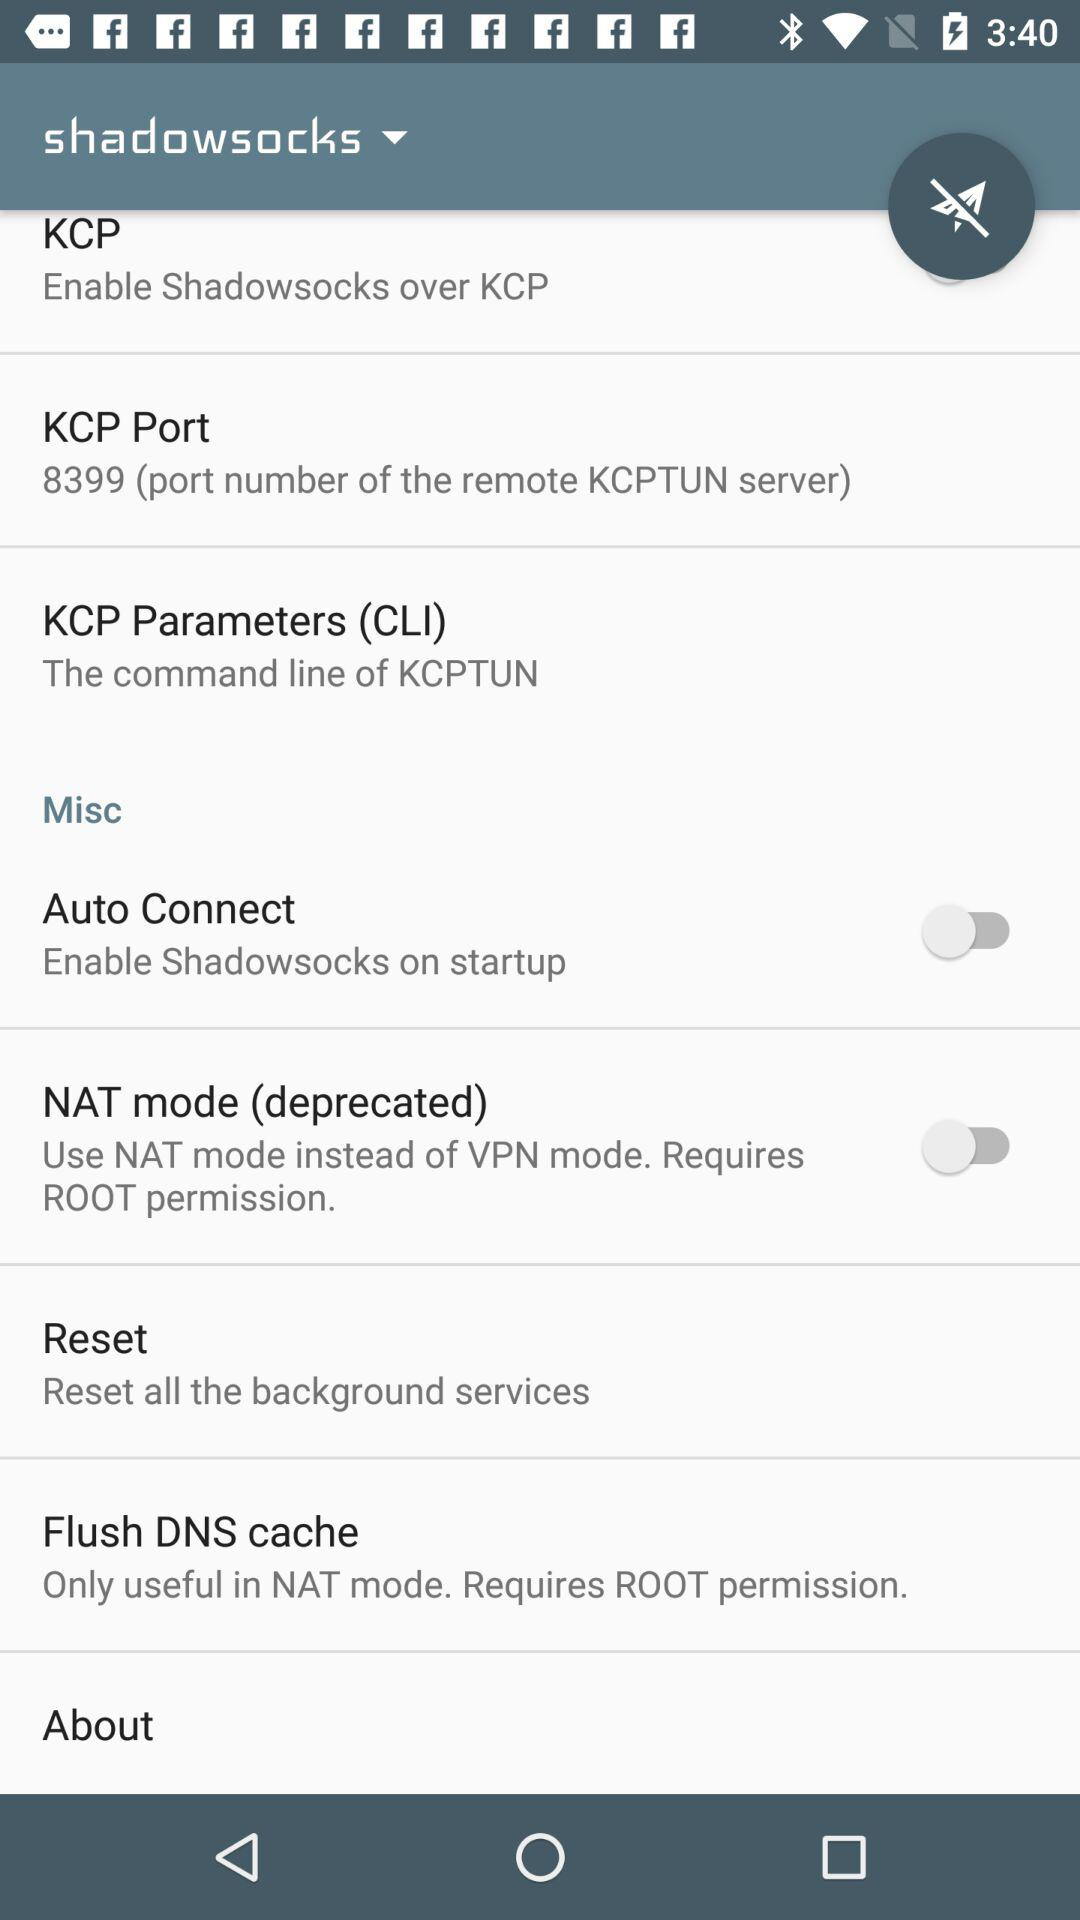What is the status of "Auto Connect"? The status of "Auto Connect" is "off". 